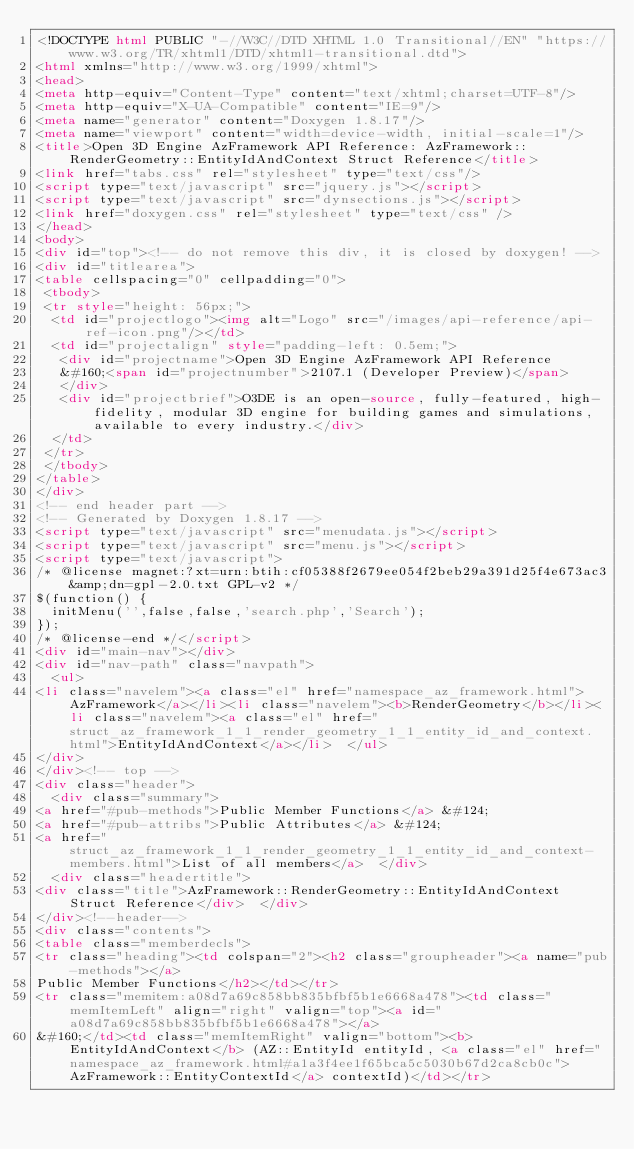Convert code to text. <code><loc_0><loc_0><loc_500><loc_500><_HTML_><!DOCTYPE html PUBLIC "-//W3C//DTD XHTML 1.0 Transitional//EN" "https://www.w3.org/TR/xhtml1/DTD/xhtml1-transitional.dtd">
<html xmlns="http://www.w3.org/1999/xhtml">
<head>
<meta http-equiv="Content-Type" content="text/xhtml;charset=UTF-8"/>
<meta http-equiv="X-UA-Compatible" content="IE=9"/>
<meta name="generator" content="Doxygen 1.8.17"/>
<meta name="viewport" content="width=device-width, initial-scale=1"/>
<title>Open 3D Engine AzFramework API Reference: AzFramework::RenderGeometry::EntityIdAndContext Struct Reference</title>
<link href="tabs.css" rel="stylesheet" type="text/css"/>
<script type="text/javascript" src="jquery.js"></script>
<script type="text/javascript" src="dynsections.js"></script>
<link href="doxygen.css" rel="stylesheet" type="text/css" />
</head>
<body>
<div id="top"><!-- do not remove this div, it is closed by doxygen! -->
<div id="titlearea">
<table cellspacing="0" cellpadding="0">
 <tbody>
 <tr style="height: 56px;">
  <td id="projectlogo"><img alt="Logo" src="/images/api-reference/api-ref-icon.png"/></td>
  <td id="projectalign" style="padding-left: 0.5em;">
   <div id="projectname">Open 3D Engine AzFramework API Reference
   &#160;<span id="projectnumber">2107.1 (Developer Preview)</span>
   </div>
   <div id="projectbrief">O3DE is an open-source, fully-featured, high-fidelity, modular 3D engine for building games and simulations, available to every industry.</div>
  </td>
 </tr>
 </tbody>
</table>
</div>
<!-- end header part -->
<!-- Generated by Doxygen 1.8.17 -->
<script type="text/javascript" src="menudata.js"></script>
<script type="text/javascript" src="menu.js"></script>
<script type="text/javascript">
/* @license magnet:?xt=urn:btih:cf05388f2679ee054f2beb29a391d25f4e673ac3&amp;dn=gpl-2.0.txt GPL-v2 */
$(function() {
  initMenu('',false,false,'search.php','Search');
});
/* @license-end */</script>
<div id="main-nav"></div>
<div id="nav-path" class="navpath">
  <ul>
<li class="navelem"><a class="el" href="namespace_az_framework.html">AzFramework</a></li><li class="navelem"><b>RenderGeometry</b></li><li class="navelem"><a class="el" href="struct_az_framework_1_1_render_geometry_1_1_entity_id_and_context.html">EntityIdAndContext</a></li>  </ul>
</div>
</div><!-- top -->
<div class="header">
  <div class="summary">
<a href="#pub-methods">Public Member Functions</a> &#124;
<a href="#pub-attribs">Public Attributes</a> &#124;
<a href="struct_az_framework_1_1_render_geometry_1_1_entity_id_and_context-members.html">List of all members</a>  </div>
  <div class="headertitle">
<div class="title">AzFramework::RenderGeometry::EntityIdAndContext Struct Reference</div>  </div>
</div><!--header-->
<div class="contents">
<table class="memberdecls">
<tr class="heading"><td colspan="2"><h2 class="groupheader"><a name="pub-methods"></a>
Public Member Functions</h2></td></tr>
<tr class="memitem:a08d7a69c858bb835bfbf5b1e6668a478"><td class="memItemLeft" align="right" valign="top"><a id="a08d7a69c858bb835bfbf5b1e6668a478"></a>
&#160;</td><td class="memItemRight" valign="bottom"><b>EntityIdAndContext</b> (AZ::EntityId entityId, <a class="el" href="namespace_az_framework.html#a1a3f4ee1f65bca5c5030b67d2ca8cb0c">AzFramework::EntityContextId</a> contextId)</td></tr></code> 